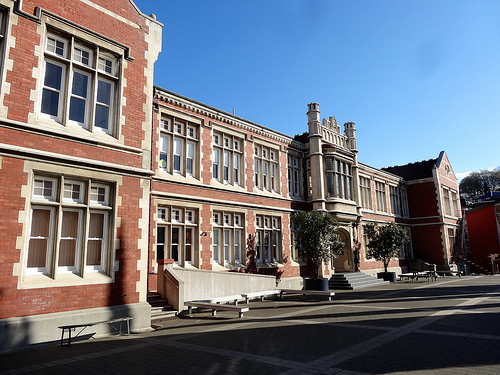<image>
Can you confirm if the tree is behind the tree? No. The tree is not behind the tree. From this viewpoint, the tree appears to be positioned elsewhere in the scene. 